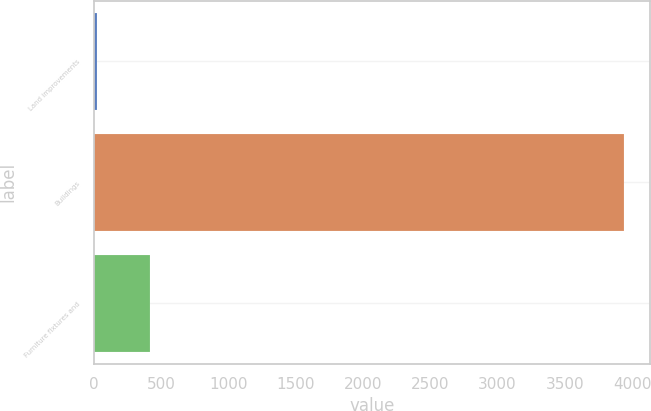<chart> <loc_0><loc_0><loc_500><loc_500><bar_chart><fcel>Land improvements<fcel>Buildings<fcel>Furniture fixtures and<nl><fcel>20<fcel>3940<fcel>412<nl></chart> 